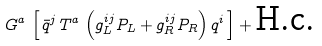Convert formula to latex. <formula><loc_0><loc_0><loc_500><loc_500>G ^ { a } \, \left [ \, \bar { q } ^ { j } \, T ^ { a } \, \left ( g ^ { i j } _ { L } P _ { L } + g ^ { i j } _ { R } P _ { R } \right ) q ^ { i } \, \right ] + \text {H.c.}</formula> 